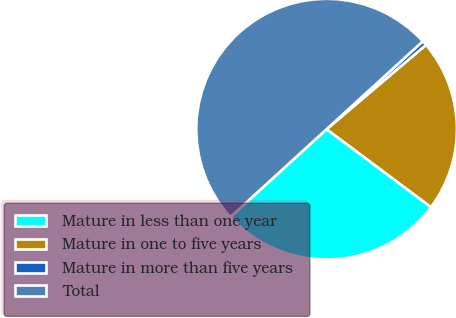<chart> <loc_0><loc_0><loc_500><loc_500><pie_chart><fcel>Mature in less than one year<fcel>Mature in one to five years<fcel>Mature in more than five years<fcel>Total<nl><fcel>28.02%<fcel>21.4%<fcel>0.59%<fcel>50.0%<nl></chart> 